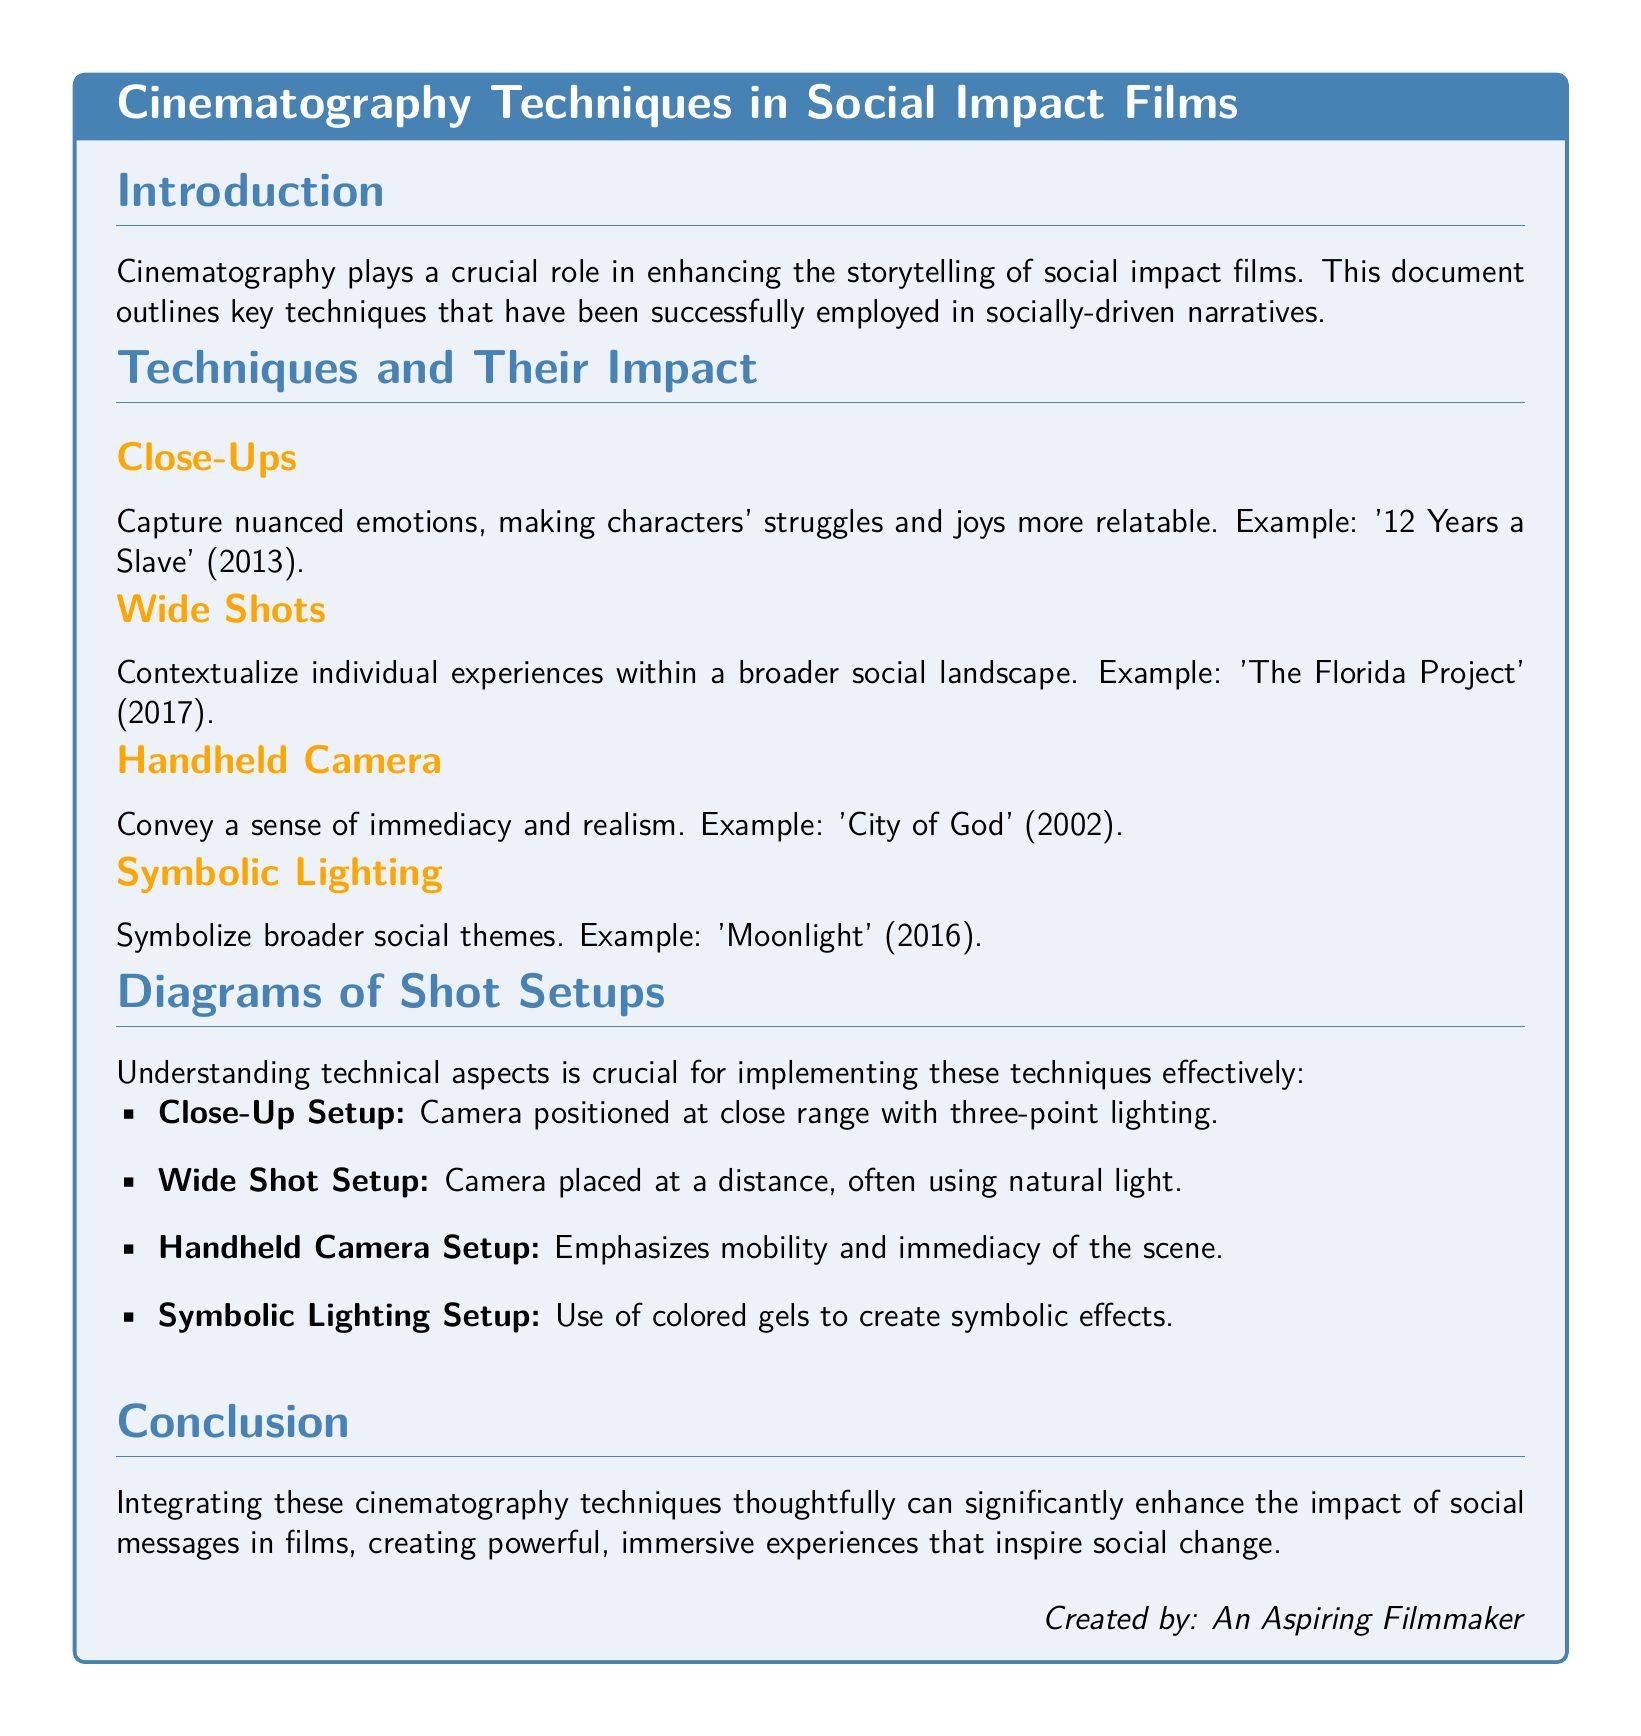What is the title of the document? The title is presented in the header of the document, which outlines the focus on cinematography techniques in social impact films.
Answer: Cinematography Techniques in Social Impact Films What are the four cinematography techniques mentioned? The techniques listed in the document detail specific methods used in social impact films that enhance storytelling.
Answer: Close-Ups, Wide Shots, Handheld Camera, Symbolic Lighting Which film is used as an example for Close-Ups? The document provides specific film references to illustrate the application of each technique.
Answer: 12 Years a Slave What does the Close-Up Setup involve? The document describes the technical setup for various cinematography techniques employed in films.
Answer: Camera positioned at close range with three-point lighting What is the purpose of Wide Shots according to the document? The document explains the context and emotional impact that specific shots bring to social narratives.
Answer: Contextualize individual experiences within a broader social landscape Which film is associated with Handheld Camera? The examples are critical for understanding the application of each cinematography technique in social impact films.
Answer: City of God What lighting technique symbolizes broader social themes? The document details various techniques and their thematic implications in storytelling through film.
Answer: Symbolic Lighting How are diagrams of shot setups categorized in the document? This structural detail reveals the technical breakdown of implementing the cinematography techniques discussed.
Answer: Itemized list What is the overall conclusion drawn in the document? The conclusion synthesizes the discussion on the impact of cinematography techniques in promoting social messages through film.
Answer: Enhance the impact of social messages 